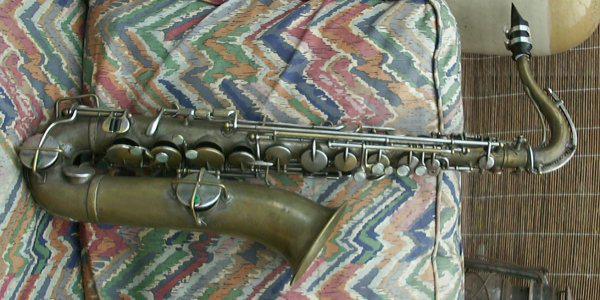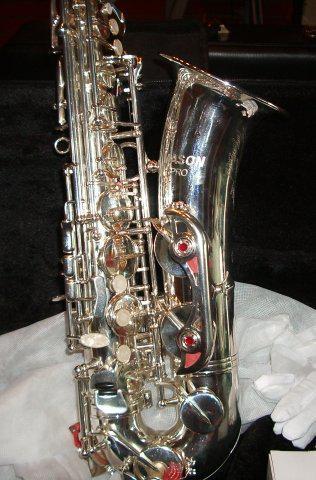The first image is the image on the left, the second image is the image on the right. Considering the images on both sides, is "The fabric underneath the instruments in one image is red." valid? Answer yes or no. No. The first image is the image on the left, the second image is the image on the right. For the images displayed, is the sentence "The left image shows a saxophone displayed horizontally, with its bell facing downward and its attached mouthpiece facing upward at the right." factually correct? Answer yes or no. Yes. 